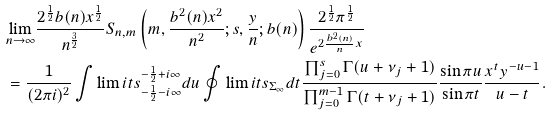Convert formula to latex. <formula><loc_0><loc_0><loc_500><loc_500>& \underset { n \rightarrow \infty } { \lim } \frac { 2 ^ { \frac { 1 } { 2 } } b ( n ) x ^ { \frac { 1 } { 2 } } } { n ^ { \frac { 3 } { 2 } } } S _ { n , m } \left ( m , \frac { b ^ { 2 } ( n ) x ^ { 2 } } { n ^ { 2 } } ; s , \frac { y } { n } ; b ( n ) \right ) \frac { 2 ^ { \frac { 1 } { 2 } } \pi ^ { \frac { 1 } { 2 } } } { e ^ { 2 \frac { b ^ { 2 } ( n ) } { n } x } } \\ & = \frac { 1 } { ( 2 \pi i ) ^ { 2 } } \int \lim i t s _ { - \frac { 1 } { 2 } - i \infty } ^ { - \frac { 1 } { 2 } + i \infty } d u \oint \lim i t s _ { \Sigma _ { \infty } } d t \frac { \prod _ { j = 0 } ^ { s } \Gamma ( u + \nu _ { j } + 1 ) } { \prod _ { j = 0 } ^ { m - 1 } \Gamma ( t + \nu _ { j } + 1 ) } \frac { \sin \pi u } { \sin \pi t } \frac { x ^ { t } y ^ { - u - 1 } } { u - t } .</formula> 